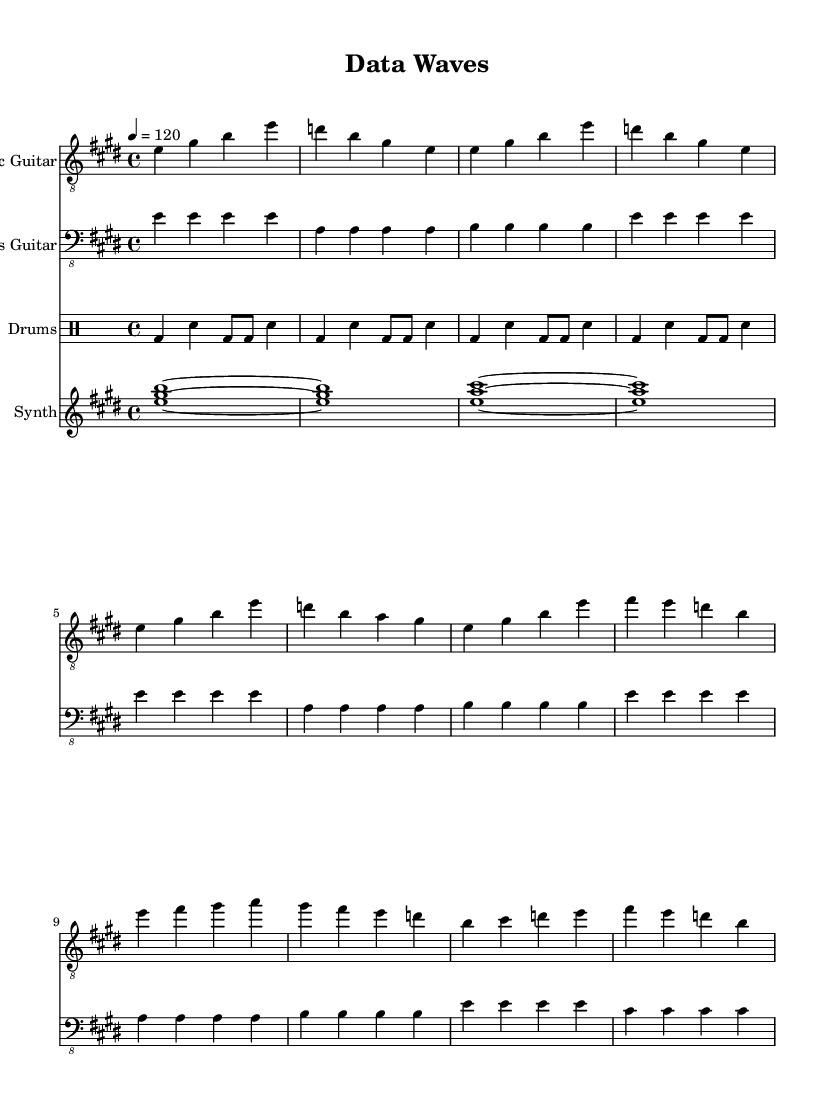What is the key signature of this music? The key signature is E major, which has four sharps: F sharp, C sharp, G sharp, and D sharp.
Answer: E major What is the time signature of this music? The time signature is 4/4, meaning there are four beats per measure and the quarter note gets one beat.
Answer: 4/4 What is the tempo marking in this sheet music? The tempo marking is 120 beats per minute, indicated by the note "4 = 120."
Answer: 120 How many measures are in the intro section for the electric guitar? The intro section consists of 4 measures, as indicated by the repeated pattern in the music.
Answer: 4 Which instrument plays the atmospheric pad sound? The atmospheric pad sound is played by the synth as indicated in the score.
Answer: Synth How many notes are utilized in the electric guitar's first measure? The first measure of the electric guitar contains 4 distinct notes: E, G sharp, B, and E.
Answer: 4 Explain the drum pattern used throughout the music. The drum pattern consists of a basic rock beat with a kick drum on the first and third beats and snare on the second and fourth beats, combined with a hi-hat pattern, creating a driving rhythm typical of rock music.
Answer: Basic rock beat 